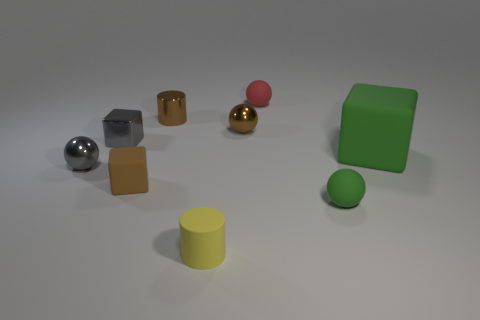Subtract all small brown spheres. How many spheres are left? 3 Subtract 1 cubes. How many cubes are left? 2 Subtract all gray balls. How many balls are left? 3 Subtract all cyan balls. Subtract all green blocks. How many balls are left? 4 Subtract all blocks. How many objects are left? 6 Subtract all large brown cylinders. Subtract all tiny gray things. How many objects are left? 7 Add 8 brown blocks. How many brown blocks are left? 9 Add 5 gray shiny objects. How many gray shiny objects exist? 7 Subtract 0 blue cubes. How many objects are left? 9 